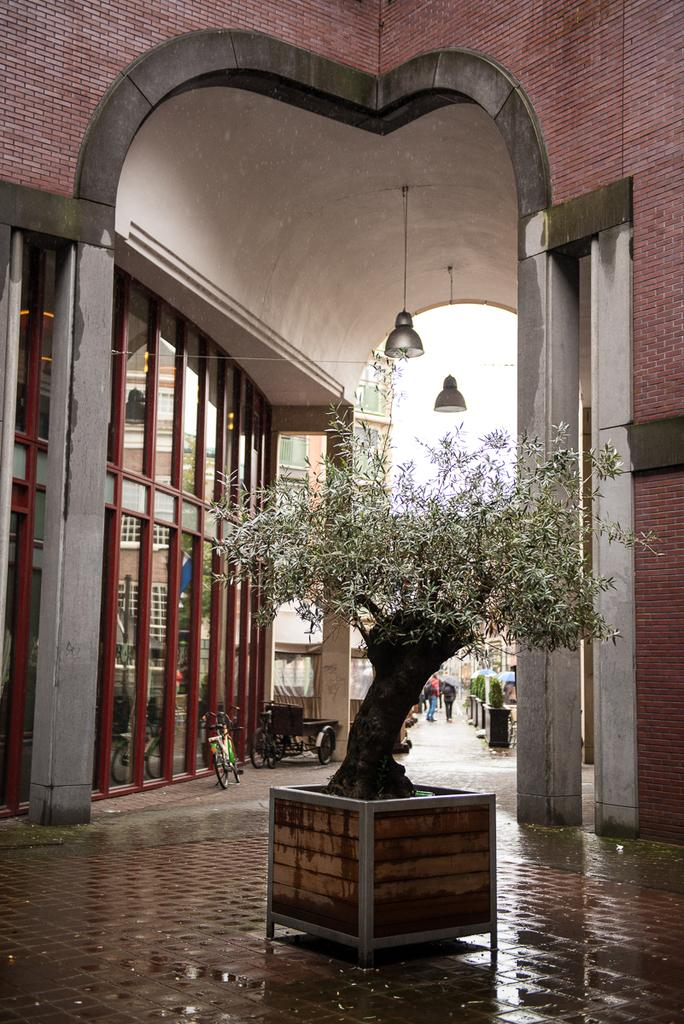What is the main subject in the center of the image? There is a plant in the center of the image. What can be seen in the background of the image? There are buildings and vehicles in the background of the image. What are the lights hanging in the image used for? The lights hanging in the image are likely used for illumination. Can you describe the people in the image? There are persons in the image, but their specific actions or characteristics are not mentioned in the provided facts. What type of mailbox can be seen near the plant in the image? There is no mailbox present in the image; it only features a plant, buildings, vehicles, and lights. What force is being applied to the persons in the image? There is no indication of any force being applied to the persons in the image, as their actions or characteristics are not mentioned in the provided facts. 